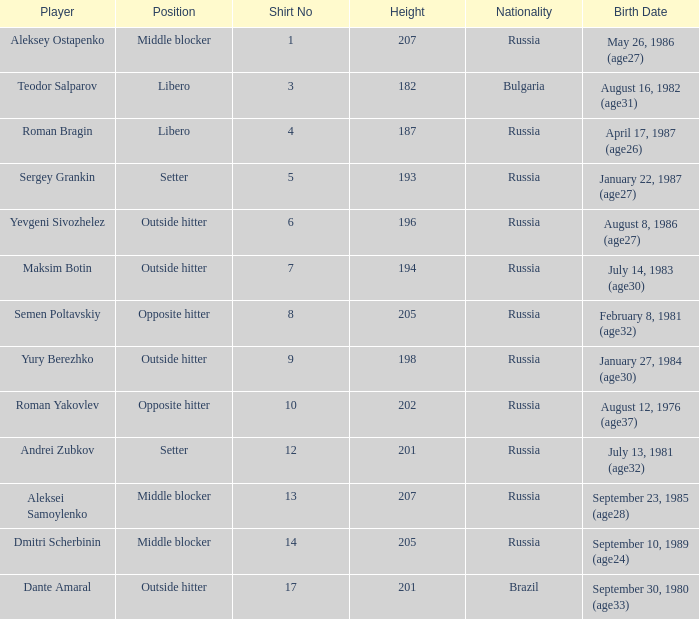How tall is Maksim Botin?  194.0. 